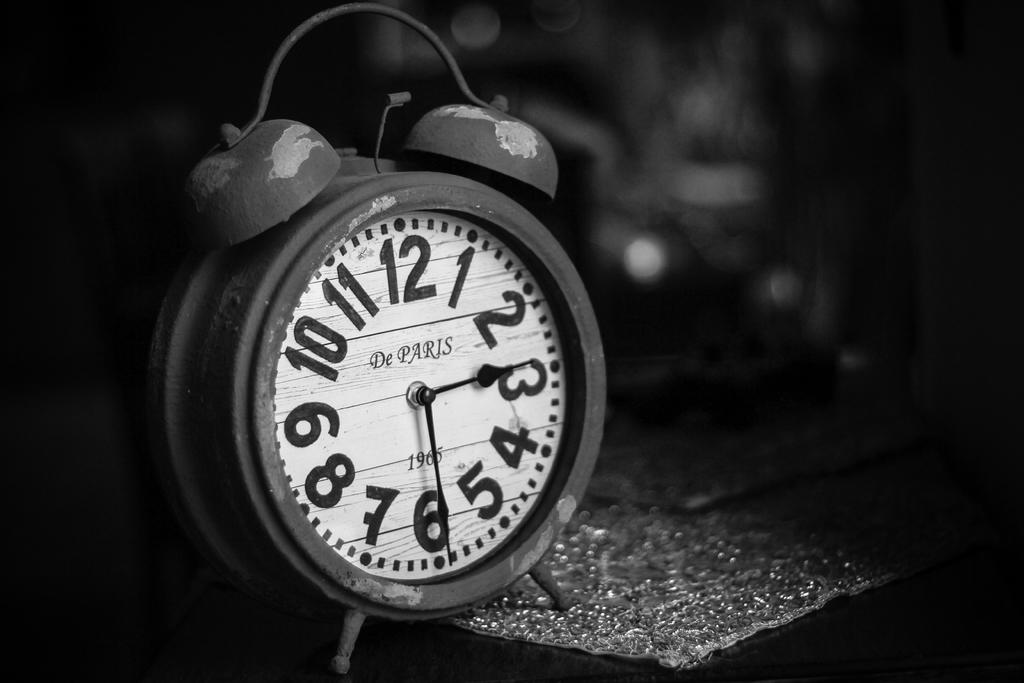<image>
Summarize the visual content of the image. A clock bearing the words De Paris and the time showing as half three. 